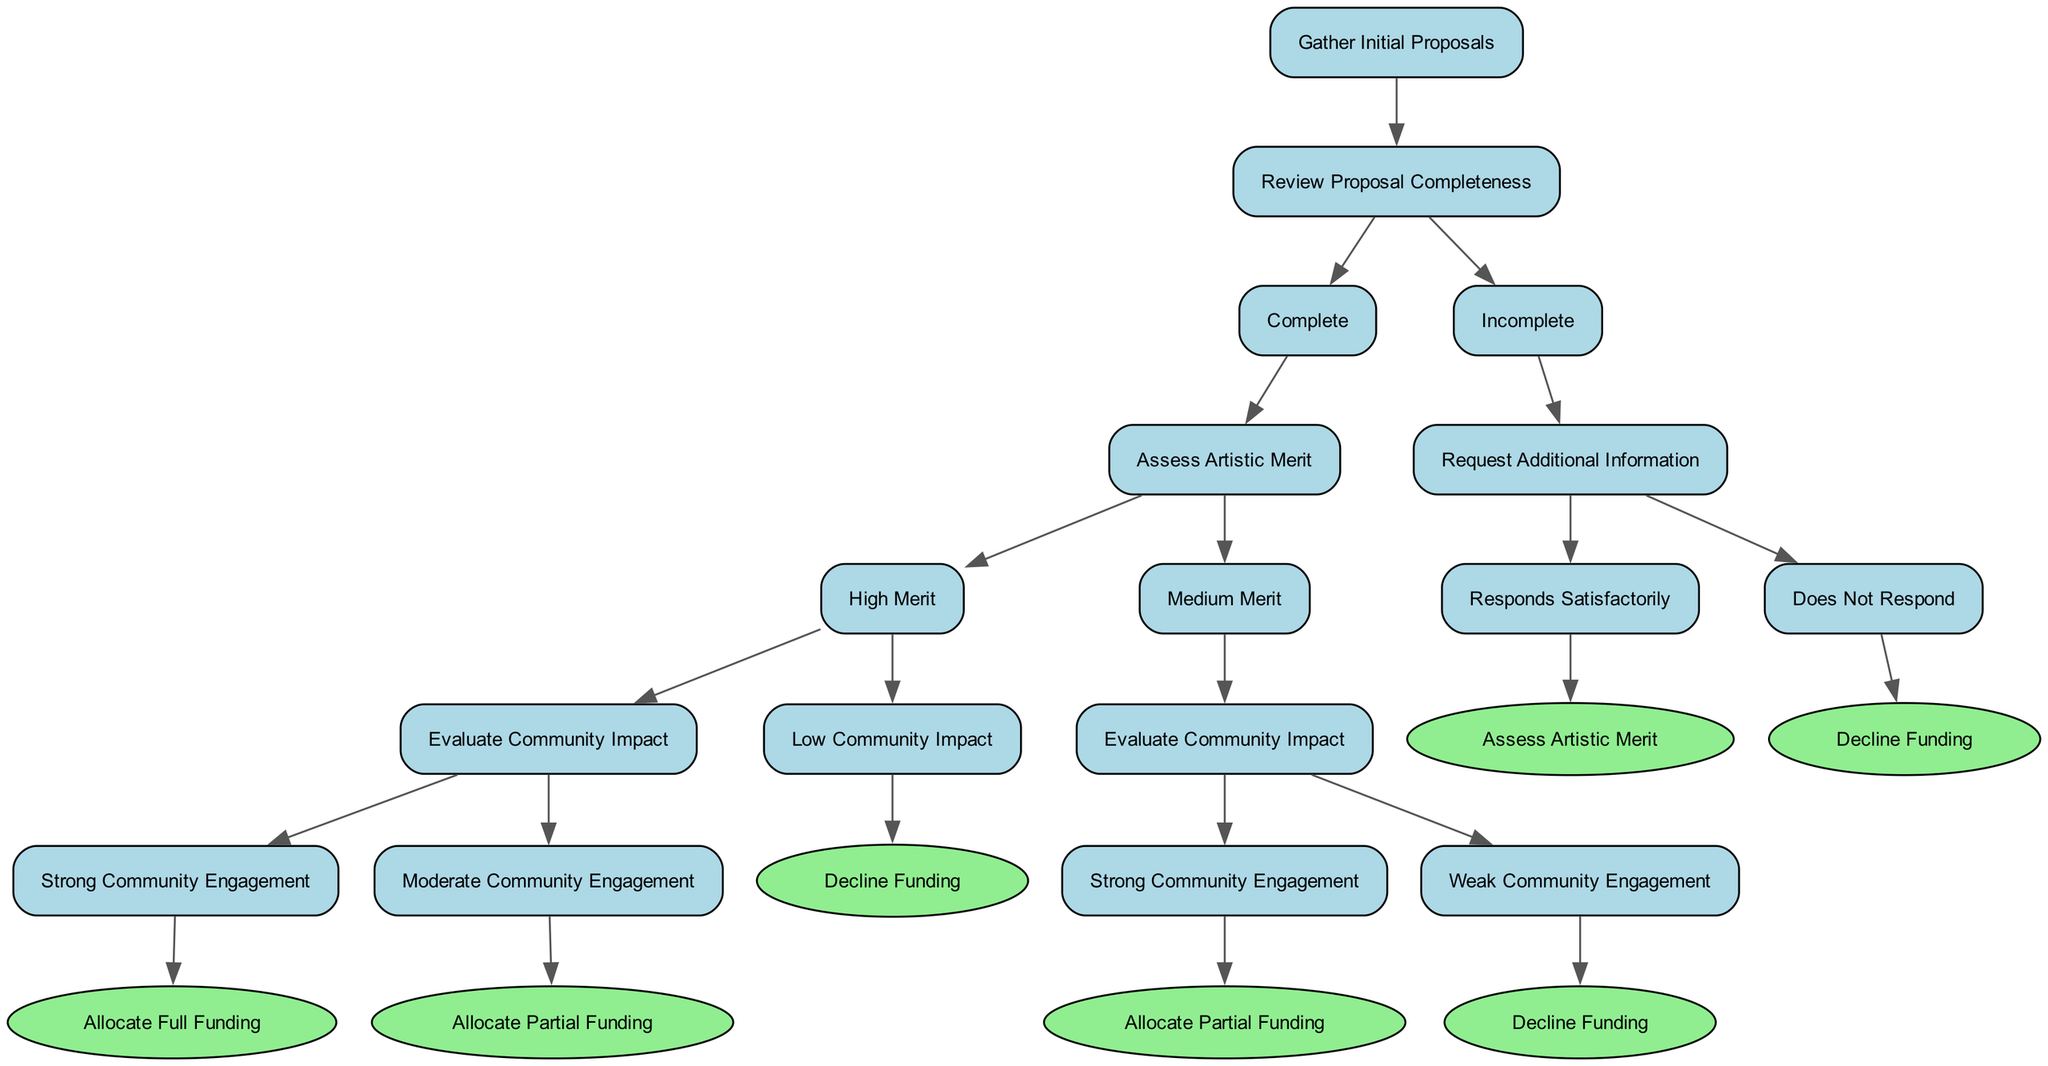What is the initial step in the decision-making process? The diagram starts with the node labeled "Gather Initial Proposals," which indicates the first action in the decision-making process.
Answer: Gather Initial Proposals How many children does the "Review Proposal Completeness" node have? The "Review Proposal Completeness" node has two children: "Complete" and "Incomplete." Counting these gives a total of two children.
Answer: 2 What funding allocation is given for "High Merit" with "Strong Community Engagement"? According to the decision path, if the merit is high and there is strong community engagement, the funding allocated is "Full Funding."
Answer: Allocate Full Funding What action follows an "Incomplete" proposal after requesting additional information? If the proposal is incomplete and additional information is requested, the next action depends on whether the organization responds satisfactorily or does not respond. If they respond satisfactorily, it proceeds to "Assess Artistic Merit."
Answer: Assess Artistic Merit If a proposal has "Medium Merit" and "Weak Community Engagement," what is the outcome? The decision flow indicates that if a proposal has medium merit and weak community engagement, the funding will be declined. Thus, the final outcome is to decline funding.
Answer: Decline Funding What is the outcome if there is "Low Community Impact" after "High Merit"? Following the flow, for a proposal with high artistic merit but low community impact, the result is to decline funding. This process shows how high artistic value can still lead to non-funding based on community impact.
Answer: Decline Funding How many funding outcomes are ultimately possible in the tree? Analyzing the nodes, three distinct outcomes regarding funding allocation can be found: "Allocate Full Funding," "Allocate Partial Funding," and "Decline Funding." Counting these gives a total of three different outcomes.
Answer: 3 What happens if a proposal is not complete and does not respond? The diagram specifies that if a proposal is incomplete, and there is no satisfactory response after requesting additional information, the organization will be declined funding. Thus, this path results in a clear non-funding decision.
Answer: Decline Funding 